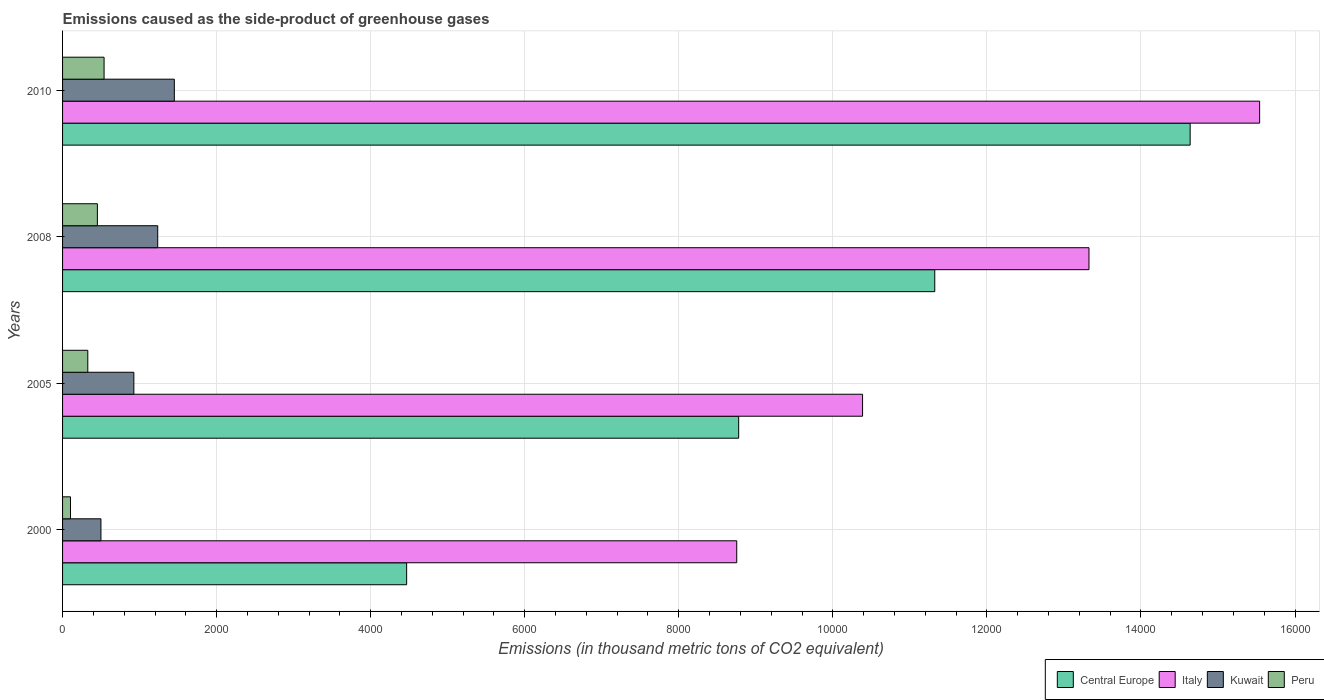How many groups of bars are there?
Offer a very short reply. 4. Are the number of bars on each tick of the Y-axis equal?
Offer a very short reply. Yes. How many bars are there on the 3rd tick from the bottom?
Give a very brief answer. 4. In how many cases, is the number of bars for a given year not equal to the number of legend labels?
Give a very brief answer. 0. What is the emissions caused as the side-product of greenhouse gases in Kuwait in 2008?
Offer a terse response. 1235.4. Across all years, what is the maximum emissions caused as the side-product of greenhouse gases in Central Europe?
Offer a very short reply. 1.46e+04. Across all years, what is the minimum emissions caused as the side-product of greenhouse gases in Italy?
Your response must be concise. 8752.3. In which year was the emissions caused as the side-product of greenhouse gases in Kuwait maximum?
Your answer should be compact. 2010. In which year was the emissions caused as the side-product of greenhouse gases in Peru minimum?
Offer a terse response. 2000. What is the total emissions caused as the side-product of greenhouse gases in Italy in the graph?
Make the answer very short. 4.80e+04. What is the difference between the emissions caused as the side-product of greenhouse gases in Italy in 2000 and that in 2010?
Provide a succinct answer. -6788.7. What is the difference between the emissions caused as the side-product of greenhouse gases in Italy in 2000 and the emissions caused as the side-product of greenhouse gases in Kuwait in 2008?
Your answer should be very brief. 7516.9. What is the average emissions caused as the side-product of greenhouse gases in Italy per year?
Provide a succinct answer. 1.20e+04. In the year 2000, what is the difference between the emissions caused as the side-product of greenhouse gases in Central Europe and emissions caused as the side-product of greenhouse gases in Peru?
Provide a short and direct response. 4363.8. In how many years, is the emissions caused as the side-product of greenhouse gases in Kuwait greater than 9200 thousand metric tons?
Provide a succinct answer. 0. What is the ratio of the emissions caused as the side-product of greenhouse gases in Central Europe in 2005 to that in 2008?
Your answer should be very brief. 0.78. Is the difference between the emissions caused as the side-product of greenhouse gases in Central Europe in 2005 and 2008 greater than the difference between the emissions caused as the side-product of greenhouse gases in Peru in 2005 and 2008?
Your response must be concise. No. What is the difference between the highest and the second highest emissions caused as the side-product of greenhouse gases in Central Europe?
Keep it short and to the point. 3315.6. What is the difference between the highest and the lowest emissions caused as the side-product of greenhouse gases in Central Europe?
Give a very brief answer. 1.02e+04. Is the sum of the emissions caused as the side-product of greenhouse gases in Kuwait in 2005 and 2010 greater than the maximum emissions caused as the side-product of greenhouse gases in Peru across all years?
Offer a terse response. Yes. Is it the case that in every year, the sum of the emissions caused as the side-product of greenhouse gases in Italy and emissions caused as the side-product of greenhouse gases in Central Europe is greater than the sum of emissions caused as the side-product of greenhouse gases in Kuwait and emissions caused as the side-product of greenhouse gases in Peru?
Your response must be concise. Yes. What does the 4th bar from the top in 2005 represents?
Ensure brevity in your answer.  Central Europe. Is it the case that in every year, the sum of the emissions caused as the side-product of greenhouse gases in Peru and emissions caused as the side-product of greenhouse gases in Kuwait is greater than the emissions caused as the side-product of greenhouse gases in Italy?
Provide a short and direct response. No. How many bars are there?
Make the answer very short. 16. Are the values on the major ticks of X-axis written in scientific E-notation?
Offer a very short reply. No. Where does the legend appear in the graph?
Your answer should be very brief. Bottom right. How many legend labels are there?
Ensure brevity in your answer.  4. How are the legend labels stacked?
Provide a succinct answer. Horizontal. What is the title of the graph?
Offer a very short reply. Emissions caused as the side-product of greenhouse gases. What is the label or title of the X-axis?
Make the answer very short. Emissions (in thousand metric tons of CO2 equivalent). What is the Emissions (in thousand metric tons of CO2 equivalent) of Central Europe in 2000?
Your answer should be compact. 4466.9. What is the Emissions (in thousand metric tons of CO2 equivalent) in Italy in 2000?
Provide a succinct answer. 8752.3. What is the Emissions (in thousand metric tons of CO2 equivalent) in Kuwait in 2000?
Keep it short and to the point. 498.2. What is the Emissions (in thousand metric tons of CO2 equivalent) of Peru in 2000?
Offer a very short reply. 103.1. What is the Emissions (in thousand metric tons of CO2 equivalent) in Central Europe in 2005?
Give a very brief answer. 8777.6. What is the Emissions (in thousand metric tons of CO2 equivalent) of Italy in 2005?
Give a very brief answer. 1.04e+04. What is the Emissions (in thousand metric tons of CO2 equivalent) in Kuwait in 2005?
Give a very brief answer. 925.6. What is the Emissions (in thousand metric tons of CO2 equivalent) in Peru in 2005?
Offer a terse response. 327.6. What is the Emissions (in thousand metric tons of CO2 equivalent) in Central Europe in 2008?
Your answer should be very brief. 1.13e+04. What is the Emissions (in thousand metric tons of CO2 equivalent) in Italy in 2008?
Keep it short and to the point. 1.33e+04. What is the Emissions (in thousand metric tons of CO2 equivalent) of Kuwait in 2008?
Provide a succinct answer. 1235.4. What is the Emissions (in thousand metric tons of CO2 equivalent) in Peru in 2008?
Give a very brief answer. 452. What is the Emissions (in thousand metric tons of CO2 equivalent) of Central Europe in 2010?
Give a very brief answer. 1.46e+04. What is the Emissions (in thousand metric tons of CO2 equivalent) in Italy in 2010?
Offer a very short reply. 1.55e+04. What is the Emissions (in thousand metric tons of CO2 equivalent) of Kuwait in 2010?
Provide a succinct answer. 1451. What is the Emissions (in thousand metric tons of CO2 equivalent) in Peru in 2010?
Your response must be concise. 539. Across all years, what is the maximum Emissions (in thousand metric tons of CO2 equivalent) of Central Europe?
Give a very brief answer. 1.46e+04. Across all years, what is the maximum Emissions (in thousand metric tons of CO2 equivalent) of Italy?
Your answer should be very brief. 1.55e+04. Across all years, what is the maximum Emissions (in thousand metric tons of CO2 equivalent) of Kuwait?
Offer a terse response. 1451. Across all years, what is the maximum Emissions (in thousand metric tons of CO2 equivalent) of Peru?
Make the answer very short. 539. Across all years, what is the minimum Emissions (in thousand metric tons of CO2 equivalent) in Central Europe?
Offer a terse response. 4466.9. Across all years, what is the minimum Emissions (in thousand metric tons of CO2 equivalent) of Italy?
Your response must be concise. 8752.3. Across all years, what is the minimum Emissions (in thousand metric tons of CO2 equivalent) of Kuwait?
Offer a very short reply. 498.2. Across all years, what is the minimum Emissions (in thousand metric tons of CO2 equivalent) of Peru?
Make the answer very short. 103.1. What is the total Emissions (in thousand metric tons of CO2 equivalent) in Central Europe in the graph?
Your answer should be compact. 3.92e+04. What is the total Emissions (in thousand metric tons of CO2 equivalent) of Italy in the graph?
Offer a terse response. 4.80e+04. What is the total Emissions (in thousand metric tons of CO2 equivalent) in Kuwait in the graph?
Give a very brief answer. 4110.2. What is the total Emissions (in thousand metric tons of CO2 equivalent) in Peru in the graph?
Offer a terse response. 1421.7. What is the difference between the Emissions (in thousand metric tons of CO2 equivalent) of Central Europe in 2000 and that in 2005?
Give a very brief answer. -4310.7. What is the difference between the Emissions (in thousand metric tons of CO2 equivalent) in Italy in 2000 and that in 2005?
Ensure brevity in your answer.  -1633.7. What is the difference between the Emissions (in thousand metric tons of CO2 equivalent) in Kuwait in 2000 and that in 2005?
Provide a short and direct response. -427.4. What is the difference between the Emissions (in thousand metric tons of CO2 equivalent) in Peru in 2000 and that in 2005?
Ensure brevity in your answer.  -224.5. What is the difference between the Emissions (in thousand metric tons of CO2 equivalent) in Central Europe in 2000 and that in 2008?
Provide a succinct answer. -6856.5. What is the difference between the Emissions (in thousand metric tons of CO2 equivalent) of Italy in 2000 and that in 2008?
Your answer should be compact. -4573.1. What is the difference between the Emissions (in thousand metric tons of CO2 equivalent) of Kuwait in 2000 and that in 2008?
Your answer should be very brief. -737.2. What is the difference between the Emissions (in thousand metric tons of CO2 equivalent) of Peru in 2000 and that in 2008?
Offer a terse response. -348.9. What is the difference between the Emissions (in thousand metric tons of CO2 equivalent) in Central Europe in 2000 and that in 2010?
Your answer should be compact. -1.02e+04. What is the difference between the Emissions (in thousand metric tons of CO2 equivalent) in Italy in 2000 and that in 2010?
Provide a succinct answer. -6788.7. What is the difference between the Emissions (in thousand metric tons of CO2 equivalent) of Kuwait in 2000 and that in 2010?
Offer a terse response. -952.8. What is the difference between the Emissions (in thousand metric tons of CO2 equivalent) of Peru in 2000 and that in 2010?
Provide a succinct answer. -435.9. What is the difference between the Emissions (in thousand metric tons of CO2 equivalent) of Central Europe in 2005 and that in 2008?
Offer a terse response. -2545.8. What is the difference between the Emissions (in thousand metric tons of CO2 equivalent) of Italy in 2005 and that in 2008?
Offer a terse response. -2939.4. What is the difference between the Emissions (in thousand metric tons of CO2 equivalent) of Kuwait in 2005 and that in 2008?
Your answer should be compact. -309.8. What is the difference between the Emissions (in thousand metric tons of CO2 equivalent) of Peru in 2005 and that in 2008?
Your answer should be compact. -124.4. What is the difference between the Emissions (in thousand metric tons of CO2 equivalent) in Central Europe in 2005 and that in 2010?
Offer a terse response. -5861.4. What is the difference between the Emissions (in thousand metric tons of CO2 equivalent) in Italy in 2005 and that in 2010?
Give a very brief answer. -5155. What is the difference between the Emissions (in thousand metric tons of CO2 equivalent) in Kuwait in 2005 and that in 2010?
Provide a short and direct response. -525.4. What is the difference between the Emissions (in thousand metric tons of CO2 equivalent) of Peru in 2005 and that in 2010?
Make the answer very short. -211.4. What is the difference between the Emissions (in thousand metric tons of CO2 equivalent) of Central Europe in 2008 and that in 2010?
Make the answer very short. -3315.6. What is the difference between the Emissions (in thousand metric tons of CO2 equivalent) of Italy in 2008 and that in 2010?
Your answer should be very brief. -2215.6. What is the difference between the Emissions (in thousand metric tons of CO2 equivalent) in Kuwait in 2008 and that in 2010?
Give a very brief answer. -215.6. What is the difference between the Emissions (in thousand metric tons of CO2 equivalent) in Peru in 2008 and that in 2010?
Your response must be concise. -87. What is the difference between the Emissions (in thousand metric tons of CO2 equivalent) of Central Europe in 2000 and the Emissions (in thousand metric tons of CO2 equivalent) of Italy in 2005?
Provide a succinct answer. -5919.1. What is the difference between the Emissions (in thousand metric tons of CO2 equivalent) of Central Europe in 2000 and the Emissions (in thousand metric tons of CO2 equivalent) of Kuwait in 2005?
Offer a terse response. 3541.3. What is the difference between the Emissions (in thousand metric tons of CO2 equivalent) of Central Europe in 2000 and the Emissions (in thousand metric tons of CO2 equivalent) of Peru in 2005?
Make the answer very short. 4139.3. What is the difference between the Emissions (in thousand metric tons of CO2 equivalent) of Italy in 2000 and the Emissions (in thousand metric tons of CO2 equivalent) of Kuwait in 2005?
Your response must be concise. 7826.7. What is the difference between the Emissions (in thousand metric tons of CO2 equivalent) of Italy in 2000 and the Emissions (in thousand metric tons of CO2 equivalent) of Peru in 2005?
Your answer should be compact. 8424.7. What is the difference between the Emissions (in thousand metric tons of CO2 equivalent) of Kuwait in 2000 and the Emissions (in thousand metric tons of CO2 equivalent) of Peru in 2005?
Provide a succinct answer. 170.6. What is the difference between the Emissions (in thousand metric tons of CO2 equivalent) in Central Europe in 2000 and the Emissions (in thousand metric tons of CO2 equivalent) in Italy in 2008?
Provide a succinct answer. -8858.5. What is the difference between the Emissions (in thousand metric tons of CO2 equivalent) of Central Europe in 2000 and the Emissions (in thousand metric tons of CO2 equivalent) of Kuwait in 2008?
Offer a very short reply. 3231.5. What is the difference between the Emissions (in thousand metric tons of CO2 equivalent) in Central Europe in 2000 and the Emissions (in thousand metric tons of CO2 equivalent) in Peru in 2008?
Offer a terse response. 4014.9. What is the difference between the Emissions (in thousand metric tons of CO2 equivalent) in Italy in 2000 and the Emissions (in thousand metric tons of CO2 equivalent) in Kuwait in 2008?
Keep it short and to the point. 7516.9. What is the difference between the Emissions (in thousand metric tons of CO2 equivalent) in Italy in 2000 and the Emissions (in thousand metric tons of CO2 equivalent) in Peru in 2008?
Offer a very short reply. 8300.3. What is the difference between the Emissions (in thousand metric tons of CO2 equivalent) in Kuwait in 2000 and the Emissions (in thousand metric tons of CO2 equivalent) in Peru in 2008?
Provide a succinct answer. 46.2. What is the difference between the Emissions (in thousand metric tons of CO2 equivalent) in Central Europe in 2000 and the Emissions (in thousand metric tons of CO2 equivalent) in Italy in 2010?
Give a very brief answer. -1.11e+04. What is the difference between the Emissions (in thousand metric tons of CO2 equivalent) in Central Europe in 2000 and the Emissions (in thousand metric tons of CO2 equivalent) in Kuwait in 2010?
Give a very brief answer. 3015.9. What is the difference between the Emissions (in thousand metric tons of CO2 equivalent) of Central Europe in 2000 and the Emissions (in thousand metric tons of CO2 equivalent) of Peru in 2010?
Your response must be concise. 3927.9. What is the difference between the Emissions (in thousand metric tons of CO2 equivalent) in Italy in 2000 and the Emissions (in thousand metric tons of CO2 equivalent) in Kuwait in 2010?
Make the answer very short. 7301.3. What is the difference between the Emissions (in thousand metric tons of CO2 equivalent) in Italy in 2000 and the Emissions (in thousand metric tons of CO2 equivalent) in Peru in 2010?
Make the answer very short. 8213.3. What is the difference between the Emissions (in thousand metric tons of CO2 equivalent) of Kuwait in 2000 and the Emissions (in thousand metric tons of CO2 equivalent) of Peru in 2010?
Provide a short and direct response. -40.8. What is the difference between the Emissions (in thousand metric tons of CO2 equivalent) in Central Europe in 2005 and the Emissions (in thousand metric tons of CO2 equivalent) in Italy in 2008?
Provide a short and direct response. -4547.8. What is the difference between the Emissions (in thousand metric tons of CO2 equivalent) of Central Europe in 2005 and the Emissions (in thousand metric tons of CO2 equivalent) of Kuwait in 2008?
Keep it short and to the point. 7542.2. What is the difference between the Emissions (in thousand metric tons of CO2 equivalent) of Central Europe in 2005 and the Emissions (in thousand metric tons of CO2 equivalent) of Peru in 2008?
Offer a very short reply. 8325.6. What is the difference between the Emissions (in thousand metric tons of CO2 equivalent) of Italy in 2005 and the Emissions (in thousand metric tons of CO2 equivalent) of Kuwait in 2008?
Give a very brief answer. 9150.6. What is the difference between the Emissions (in thousand metric tons of CO2 equivalent) of Italy in 2005 and the Emissions (in thousand metric tons of CO2 equivalent) of Peru in 2008?
Your response must be concise. 9934. What is the difference between the Emissions (in thousand metric tons of CO2 equivalent) of Kuwait in 2005 and the Emissions (in thousand metric tons of CO2 equivalent) of Peru in 2008?
Your answer should be compact. 473.6. What is the difference between the Emissions (in thousand metric tons of CO2 equivalent) of Central Europe in 2005 and the Emissions (in thousand metric tons of CO2 equivalent) of Italy in 2010?
Provide a succinct answer. -6763.4. What is the difference between the Emissions (in thousand metric tons of CO2 equivalent) in Central Europe in 2005 and the Emissions (in thousand metric tons of CO2 equivalent) in Kuwait in 2010?
Give a very brief answer. 7326.6. What is the difference between the Emissions (in thousand metric tons of CO2 equivalent) in Central Europe in 2005 and the Emissions (in thousand metric tons of CO2 equivalent) in Peru in 2010?
Make the answer very short. 8238.6. What is the difference between the Emissions (in thousand metric tons of CO2 equivalent) in Italy in 2005 and the Emissions (in thousand metric tons of CO2 equivalent) in Kuwait in 2010?
Provide a short and direct response. 8935. What is the difference between the Emissions (in thousand metric tons of CO2 equivalent) in Italy in 2005 and the Emissions (in thousand metric tons of CO2 equivalent) in Peru in 2010?
Keep it short and to the point. 9847. What is the difference between the Emissions (in thousand metric tons of CO2 equivalent) in Kuwait in 2005 and the Emissions (in thousand metric tons of CO2 equivalent) in Peru in 2010?
Give a very brief answer. 386.6. What is the difference between the Emissions (in thousand metric tons of CO2 equivalent) of Central Europe in 2008 and the Emissions (in thousand metric tons of CO2 equivalent) of Italy in 2010?
Give a very brief answer. -4217.6. What is the difference between the Emissions (in thousand metric tons of CO2 equivalent) in Central Europe in 2008 and the Emissions (in thousand metric tons of CO2 equivalent) in Kuwait in 2010?
Provide a succinct answer. 9872.4. What is the difference between the Emissions (in thousand metric tons of CO2 equivalent) in Central Europe in 2008 and the Emissions (in thousand metric tons of CO2 equivalent) in Peru in 2010?
Give a very brief answer. 1.08e+04. What is the difference between the Emissions (in thousand metric tons of CO2 equivalent) in Italy in 2008 and the Emissions (in thousand metric tons of CO2 equivalent) in Kuwait in 2010?
Provide a short and direct response. 1.19e+04. What is the difference between the Emissions (in thousand metric tons of CO2 equivalent) of Italy in 2008 and the Emissions (in thousand metric tons of CO2 equivalent) of Peru in 2010?
Give a very brief answer. 1.28e+04. What is the difference between the Emissions (in thousand metric tons of CO2 equivalent) of Kuwait in 2008 and the Emissions (in thousand metric tons of CO2 equivalent) of Peru in 2010?
Your answer should be compact. 696.4. What is the average Emissions (in thousand metric tons of CO2 equivalent) of Central Europe per year?
Provide a succinct answer. 9801.73. What is the average Emissions (in thousand metric tons of CO2 equivalent) of Italy per year?
Give a very brief answer. 1.20e+04. What is the average Emissions (in thousand metric tons of CO2 equivalent) in Kuwait per year?
Your answer should be compact. 1027.55. What is the average Emissions (in thousand metric tons of CO2 equivalent) in Peru per year?
Your answer should be compact. 355.43. In the year 2000, what is the difference between the Emissions (in thousand metric tons of CO2 equivalent) of Central Europe and Emissions (in thousand metric tons of CO2 equivalent) of Italy?
Provide a succinct answer. -4285.4. In the year 2000, what is the difference between the Emissions (in thousand metric tons of CO2 equivalent) in Central Europe and Emissions (in thousand metric tons of CO2 equivalent) in Kuwait?
Provide a succinct answer. 3968.7. In the year 2000, what is the difference between the Emissions (in thousand metric tons of CO2 equivalent) in Central Europe and Emissions (in thousand metric tons of CO2 equivalent) in Peru?
Give a very brief answer. 4363.8. In the year 2000, what is the difference between the Emissions (in thousand metric tons of CO2 equivalent) of Italy and Emissions (in thousand metric tons of CO2 equivalent) of Kuwait?
Keep it short and to the point. 8254.1. In the year 2000, what is the difference between the Emissions (in thousand metric tons of CO2 equivalent) in Italy and Emissions (in thousand metric tons of CO2 equivalent) in Peru?
Make the answer very short. 8649.2. In the year 2000, what is the difference between the Emissions (in thousand metric tons of CO2 equivalent) in Kuwait and Emissions (in thousand metric tons of CO2 equivalent) in Peru?
Offer a terse response. 395.1. In the year 2005, what is the difference between the Emissions (in thousand metric tons of CO2 equivalent) in Central Europe and Emissions (in thousand metric tons of CO2 equivalent) in Italy?
Offer a terse response. -1608.4. In the year 2005, what is the difference between the Emissions (in thousand metric tons of CO2 equivalent) of Central Europe and Emissions (in thousand metric tons of CO2 equivalent) of Kuwait?
Give a very brief answer. 7852. In the year 2005, what is the difference between the Emissions (in thousand metric tons of CO2 equivalent) of Central Europe and Emissions (in thousand metric tons of CO2 equivalent) of Peru?
Make the answer very short. 8450. In the year 2005, what is the difference between the Emissions (in thousand metric tons of CO2 equivalent) of Italy and Emissions (in thousand metric tons of CO2 equivalent) of Kuwait?
Your answer should be compact. 9460.4. In the year 2005, what is the difference between the Emissions (in thousand metric tons of CO2 equivalent) in Italy and Emissions (in thousand metric tons of CO2 equivalent) in Peru?
Ensure brevity in your answer.  1.01e+04. In the year 2005, what is the difference between the Emissions (in thousand metric tons of CO2 equivalent) in Kuwait and Emissions (in thousand metric tons of CO2 equivalent) in Peru?
Ensure brevity in your answer.  598. In the year 2008, what is the difference between the Emissions (in thousand metric tons of CO2 equivalent) of Central Europe and Emissions (in thousand metric tons of CO2 equivalent) of Italy?
Give a very brief answer. -2002. In the year 2008, what is the difference between the Emissions (in thousand metric tons of CO2 equivalent) of Central Europe and Emissions (in thousand metric tons of CO2 equivalent) of Kuwait?
Your response must be concise. 1.01e+04. In the year 2008, what is the difference between the Emissions (in thousand metric tons of CO2 equivalent) in Central Europe and Emissions (in thousand metric tons of CO2 equivalent) in Peru?
Offer a very short reply. 1.09e+04. In the year 2008, what is the difference between the Emissions (in thousand metric tons of CO2 equivalent) of Italy and Emissions (in thousand metric tons of CO2 equivalent) of Kuwait?
Ensure brevity in your answer.  1.21e+04. In the year 2008, what is the difference between the Emissions (in thousand metric tons of CO2 equivalent) of Italy and Emissions (in thousand metric tons of CO2 equivalent) of Peru?
Your answer should be very brief. 1.29e+04. In the year 2008, what is the difference between the Emissions (in thousand metric tons of CO2 equivalent) of Kuwait and Emissions (in thousand metric tons of CO2 equivalent) of Peru?
Provide a short and direct response. 783.4. In the year 2010, what is the difference between the Emissions (in thousand metric tons of CO2 equivalent) of Central Europe and Emissions (in thousand metric tons of CO2 equivalent) of Italy?
Ensure brevity in your answer.  -902. In the year 2010, what is the difference between the Emissions (in thousand metric tons of CO2 equivalent) of Central Europe and Emissions (in thousand metric tons of CO2 equivalent) of Kuwait?
Keep it short and to the point. 1.32e+04. In the year 2010, what is the difference between the Emissions (in thousand metric tons of CO2 equivalent) of Central Europe and Emissions (in thousand metric tons of CO2 equivalent) of Peru?
Provide a short and direct response. 1.41e+04. In the year 2010, what is the difference between the Emissions (in thousand metric tons of CO2 equivalent) of Italy and Emissions (in thousand metric tons of CO2 equivalent) of Kuwait?
Make the answer very short. 1.41e+04. In the year 2010, what is the difference between the Emissions (in thousand metric tons of CO2 equivalent) in Italy and Emissions (in thousand metric tons of CO2 equivalent) in Peru?
Give a very brief answer. 1.50e+04. In the year 2010, what is the difference between the Emissions (in thousand metric tons of CO2 equivalent) of Kuwait and Emissions (in thousand metric tons of CO2 equivalent) of Peru?
Ensure brevity in your answer.  912. What is the ratio of the Emissions (in thousand metric tons of CO2 equivalent) in Central Europe in 2000 to that in 2005?
Keep it short and to the point. 0.51. What is the ratio of the Emissions (in thousand metric tons of CO2 equivalent) of Italy in 2000 to that in 2005?
Offer a very short reply. 0.84. What is the ratio of the Emissions (in thousand metric tons of CO2 equivalent) of Kuwait in 2000 to that in 2005?
Provide a short and direct response. 0.54. What is the ratio of the Emissions (in thousand metric tons of CO2 equivalent) in Peru in 2000 to that in 2005?
Offer a terse response. 0.31. What is the ratio of the Emissions (in thousand metric tons of CO2 equivalent) of Central Europe in 2000 to that in 2008?
Ensure brevity in your answer.  0.39. What is the ratio of the Emissions (in thousand metric tons of CO2 equivalent) of Italy in 2000 to that in 2008?
Offer a terse response. 0.66. What is the ratio of the Emissions (in thousand metric tons of CO2 equivalent) of Kuwait in 2000 to that in 2008?
Offer a terse response. 0.4. What is the ratio of the Emissions (in thousand metric tons of CO2 equivalent) of Peru in 2000 to that in 2008?
Provide a short and direct response. 0.23. What is the ratio of the Emissions (in thousand metric tons of CO2 equivalent) in Central Europe in 2000 to that in 2010?
Ensure brevity in your answer.  0.31. What is the ratio of the Emissions (in thousand metric tons of CO2 equivalent) in Italy in 2000 to that in 2010?
Your response must be concise. 0.56. What is the ratio of the Emissions (in thousand metric tons of CO2 equivalent) of Kuwait in 2000 to that in 2010?
Your answer should be very brief. 0.34. What is the ratio of the Emissions (in thousand metric tons of CO2 equivalent) in Peru in 2000 to that in 2010?
Provide a succinct answer. 0.19. What is the ratio of the Emissions (in thousand metric tons of CO2 equivalent) in Central Europe in 2005 to that in 2008?
Your answer should be very brief. 0.78. What is the ratio of the Emissions (in thousand metric tons of CO2 equivalent) of Italy in 2005 to that in 2008?
Your answer should be very brief. 0.78. What is the ratio of the Emissions (in thousand metric tons of CO2 equivalent) of Kuwait in 2005 to that in 2008?
Offer a very short reply. 0.75. What is the ratio of the Emissions (in thousand metric tons of CO2 equivalent) in Peru in 2005 to that in 2008?
Your answer should be compact. 0.72. What is the ratio of the Emissions (in thousand metric tons of CO2 equivalent) in Central Europe in 2005 to that in 2010?
Your answer should be very brief. 0.6. What is the ratio of the Emissions (in thousand metric tons of CO2 equivalent) in Italy in 2005 to that in 2010?
Keep it short and to the point. 0.67. What is the ratio of the Emissions (in thousand metric tons of CO2 equivalent) of Kuwait in 2005 to that in 2010?
Your answer should be compact. 0.64. What is the ratio of the Emissions (in thousand metric tons of CO2 equivalent) in Peru in 2005 to that in 2010?
Offer a terse response. 0.61. What is the ratio of the Emissions (in thousand metric tons of CO2 equivalent) in Central Europe in 2008 to that in 2010?
Make the answer very short. 0.77. What is the ratio of the Emissions (in thousand metric tons of CO2 equivalent) in Italy in 2008 to that in 2010?
Offer a very short reply. 0.86. What is the ratio of the Emissions (in thousand metric tons of CO2 equivalent) in Kuwait in 2008 to that in 2010?
Ensure brevity in your answer.  0.85. What is the ratio of the Emissions (in thousand metric tons of CO2 equivalent) of Peru in 2008 to that in 2010?
Keep it short and to the point. 0.84. What is the difference between the highest and the second highest Emissions (in thousand metric tons of CO2 equivalent) in Central Europe?
Provide a succinct answer. 3315.6. What is the difference between the highest and the second highest Emissions (in thousand metric tons of CO2 equivalent) in Italy?
Your answer should be compact. 2215.6. What is the difference between the highest and the second highest Emissions (in thousand metric tons of CO2 equivalent) in Kuwait?
Your answer should be very brief. 215.6. What is the difference between the highest and the lowest Emissions (in thousand metric tons of CO2 equivalent) in Central Europe?
Offer a terse response. 1.02e+04. What is the difference between the highest and the lowest Emissions (in thousand metric tons of CO2 equivalent) in Italy?
Make the answer very short. 6788.7. What is the difference between the highest and the lowest Emissions (in thousand metric tons of CO2 equivalent) in Kuwait?
Give a very brief answer. 952.8. What is the difference between the highest and the lowest Emissions (in thousand metric tons of CO2 equivalent) of Peru?
Your response must be concise. 435.9. 